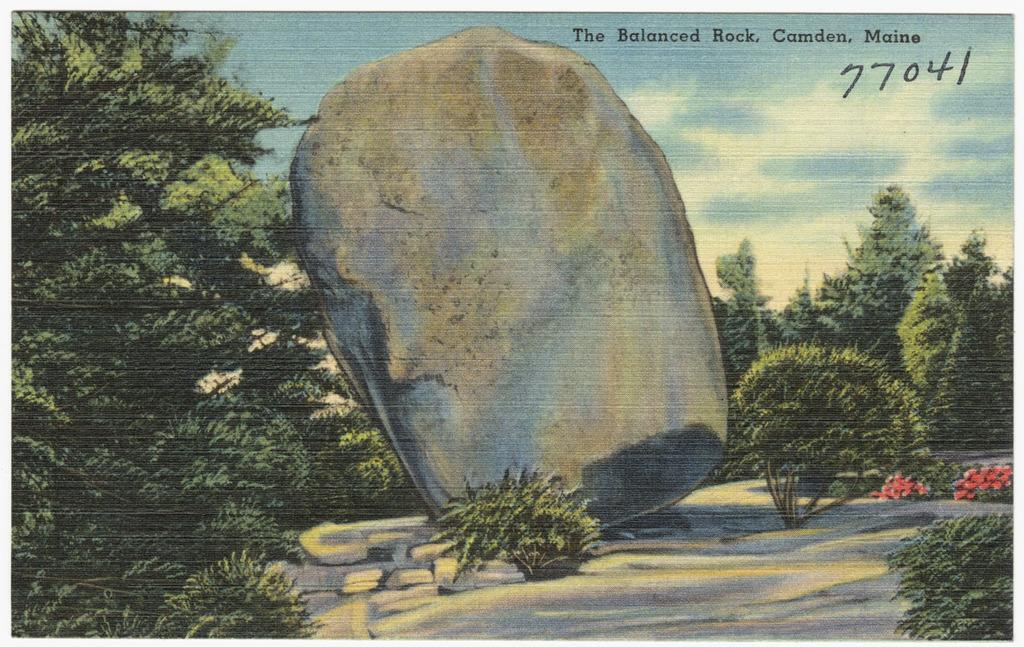Provide a one-sentence caption for the provided image. A drawing of a large rock named "The Balanced Rock". 